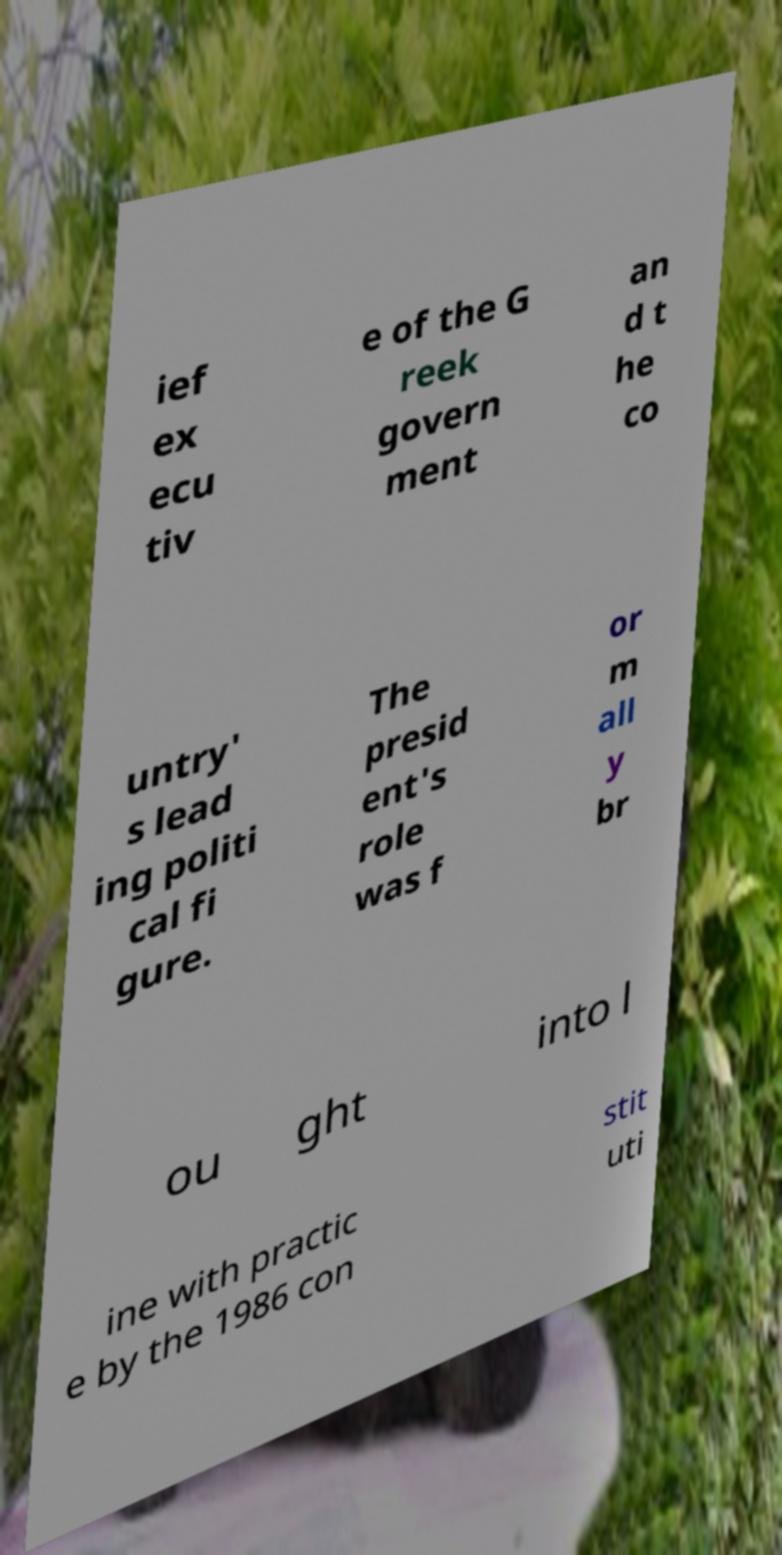There's text embedded in this image that I need extracted. Can you transcribe it verbatim? ief ex ecu tiv e of the G reek govern ment an d t he co untry' s lead ing politi cal fi gure. The presid ent's role was f or m all y br ou ght into l ine with practic e by the 1986 con stit uti 